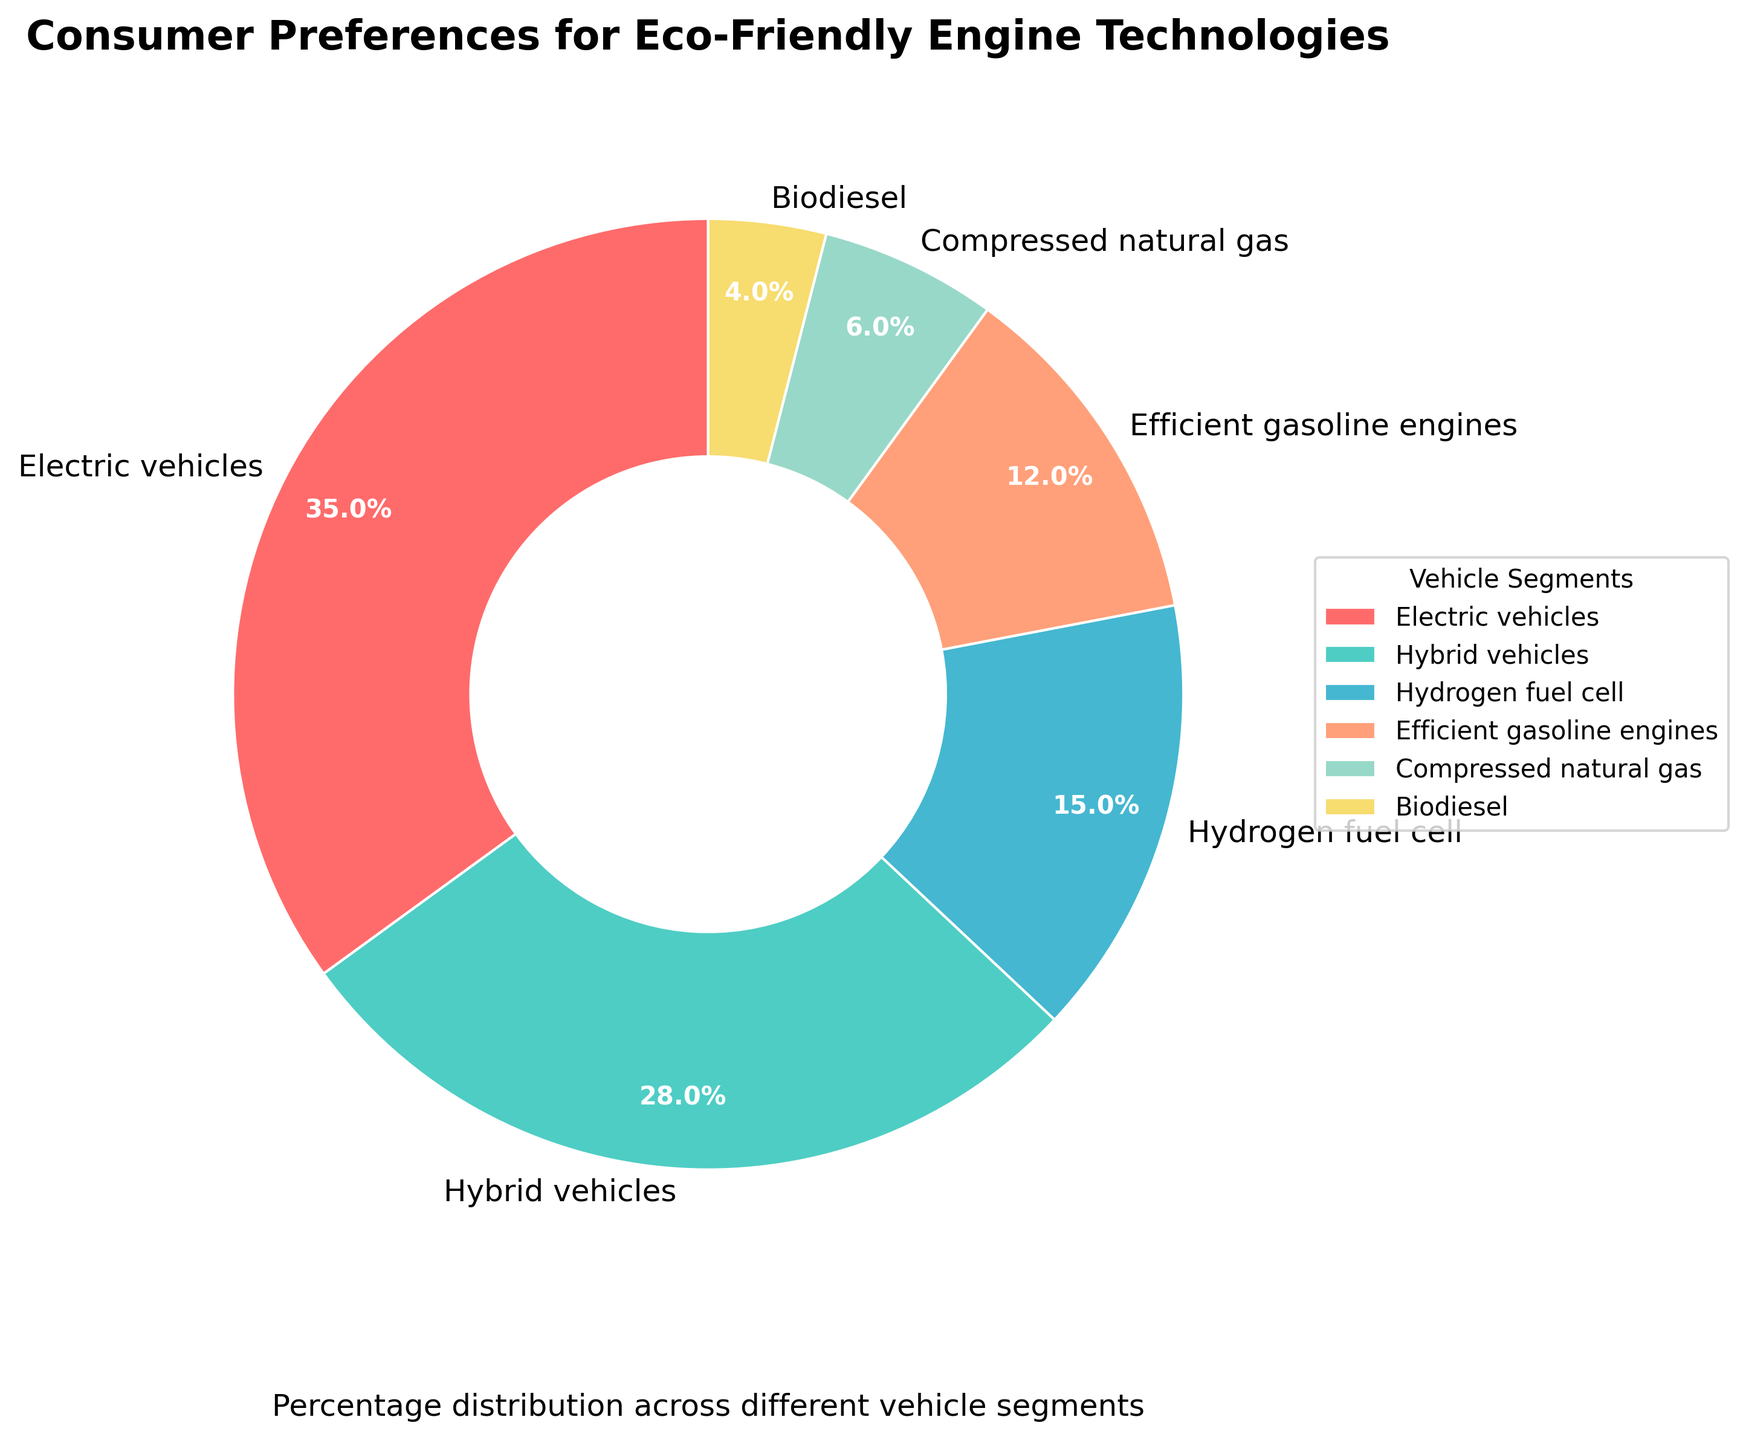Which vehicle segment has the highest preference? By observing the percentage values in the pie chart, we can see that the segment with the highest percentage is "Electric vehicles" at 35%.
Answer: Electric vehicles Which vehicle segment has the lowest preference? By observing the percentage values in the pie chart, it is clear that the segment with the lowest percentage is "Biodiesel" at 4%.
Answer: Biodiesel What is the combined preference for Hybrid vehicles and Hydrogen fuel cell vehicles? To find the combined preference, sum the percentages for Hybrid vehicles and Hydrogen fuel cell vehicles. Hybrid vehicles have 28% and Hydrogen fuel cell has 15%, so 28% + 15% = 43%.
Answer: 43% How much more preference do Efficient gasoline engines have compared to Compressed natural gas vehicles? Subtract the percentage of Compressed natural gas vehicles from Efficient gasoline engines. Efficient gasoline engines have 12% and Compressed natural gas has 6%, so 12% - 6% = 6%.
Answer: 6% What is the second most preferred vehicle segment? The second highest percentage after Electric vehicles (35%) is found in Hybrid vehicles, which have 28%.
Answer: Hybrid vehicles Which two segments have a combined preference exactly equal to that of Electric vehicles? We need to find two segments whose combined percentage equals 35%. The segments that fit this are Hybrid vehicles (28%) and Compressed natural gas (6%), as 28% + 6% = 34%, which is not equal. Upon reconsidering, Hybrid vehicles and Biodiesel equal to 32%, Efficient gasoline engines and Hydrogen fuel cell vehicles add up to 27%, none equal 35%.
Answer: None What is the difference in preference between the most and least preferred segments? Subtract the percentage of the least preferred segment (Biodiesel, 4%) from that of the most preferred segment (Electric vehicles, 35%), so 35% - 4% = 31%.
Answer: 31% What percentage of the total preference do Electric vehicles and Hybrid vehicles together represent? Sum the percentages for Electric vehicles (35%) and Hybrid vehicles (28%). The combined percentage is 35% + 28% = 63%.
Answer: 63% If the preferences for biodiesel doubled, what would its new percentage be? Doubling the current percentage of Biodiesel (4%) results in 4% * 2 = 8%.
Answer: 8% What segment uses the color green in the pie chart? Observing the color coding in the pie chart, Hybrid vehicles are represented by the color green.
Answer: Hybrid vehicles 